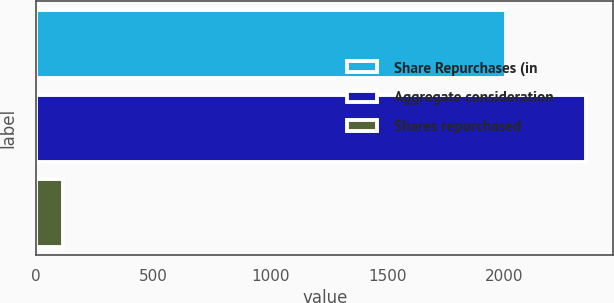Convert chart to OTSL. <chart><loc_0><loc_0><loc_500><loc_500><bar_chart><fcel>Share Repurchases (in<fcel>Aggregate consideration<fcel>Shares repurchased<nl><fcel>2006<fcel>2347<fcel>113<nl></chart> 